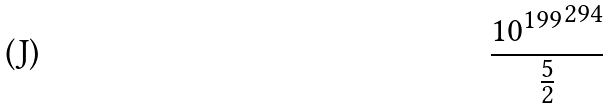<formula> <loc_0><loc_0><loc_500><loc_500>\frac { { 1 0 ^ { 1 9 9 } } ^ { 2 9 4 } } { \frac { 5 } { 2 } }</formula> 